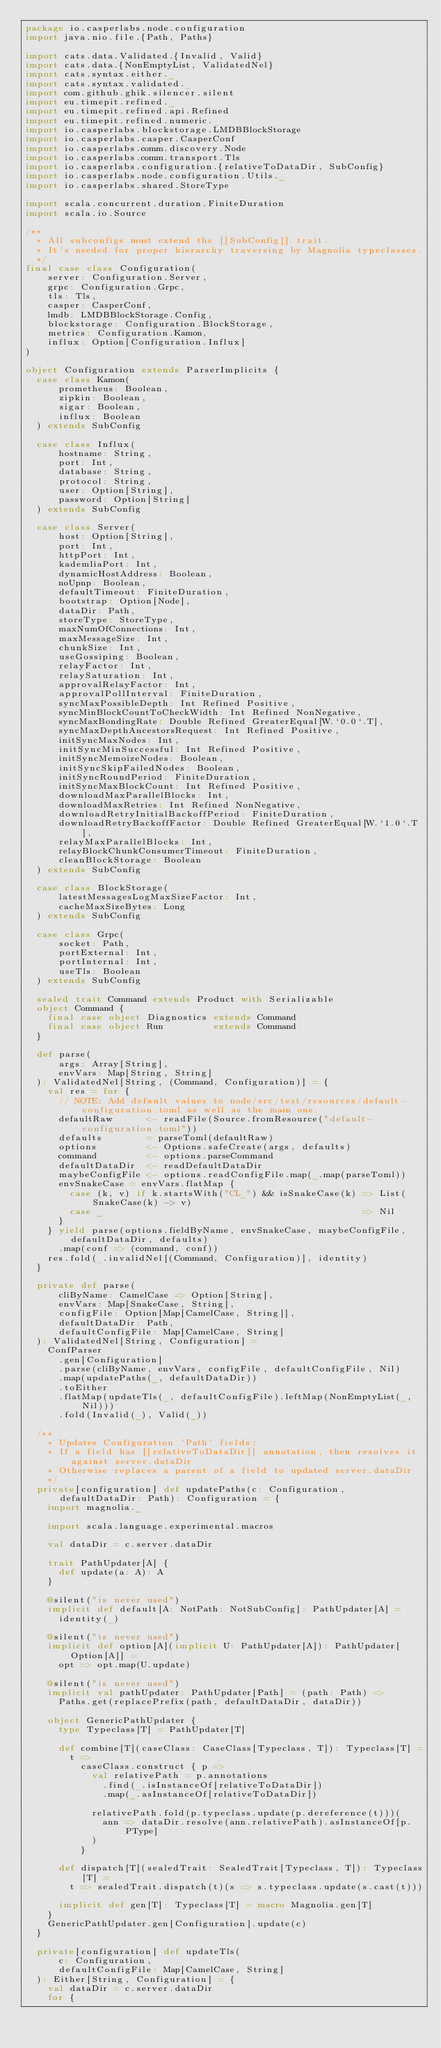Convert code to text. <code><loc_0><loc_0><loc_500><loc_500><_Scala_>package io.casperlabs.node.configuration
import java.nio.file.{Path, Paths}

import cats.data.Validated.{Invalid, Valid}
import cats.data.{NonEmptyList, ValidatedNel}
import cats.syntax.either._
import cats.syntax.validated._
import com.github.ghik.silencer.silent
import eu.timepit.refined._
import eu.timepit.refined.api.Refined
import eu.timepit.refined.numeric._
import io.casperlabs.blockstorage.LMDBBlockStorage
import io.casperlabs.casper.CasperConf
import io.casperlabs.comm.discovery.Node
import io.casperlabs.comm.transport.Tls
import io.casperlabs.configuration.{relativeToDataDir, SubConfig}
import io.casperlabs.node.configuration.Utils._
import io.casperlabs.shared.StoreType

import scala.concurrent.duration.FiniteDuration
import scala.io.Source

/**
  * All subconfigs must extend the [[SubConfig]] trait.
  * It's needed for proper hierarchy traversing by Magnolia typeclasses.
  */
final case class Configuration(
    server: Configuration.Server,
    grpc: Configuration.Grpc,
    tls: Tls,
    casper: CasperConf,
    lmdb: LMDBBlockStorage.Config,
    blockstorage: Configuration.BlockStorage,
    metrics: Configuration.Kamon,
    influx: Option[Configuration.Influx]
)

object Configuration extends ParserImplicits {
  case class Kamon(
      prometheus: Boolean,
      zipkin: Boolean,
      sigar: Boolean,
      influx: Boolean
  ) extends SubConfig

  case class Influx(
      hostname: String,
      port: Int,
      database: String,
      protocol: String,
      user: Option[String],
      password: Option[String]
  ) extends SubConfig

  case class Server(
      host: Option[String],
      port: Int,
      httpPort: Int,
      kademliaPort: Int,
      dynamicHostAddress: Boolean,
      noUpnp: Boolean,
      defaultTimeout: FiniteDuration,
      bootstrap: Option[Node],
      dataDir: Path,
      storeType: StoreType,
      maxNumOfConnections: Int,
      maxMessageSize: Int,
      chunkSize: Int,
      useGossiping: Boolean,
      relayFactor: Int,
      relaySaturation: Int,
      approvalRelayFactor: Int,
      approvalPollInterval: FiniteDuration,
      syncMaxPossibleDepth: Int Refined Positive,
      syncMinBlockCountToCheckWidth: Int Refined NonNegative,
      syncMaxBondingRate: Double Refined GreaterEqual[W.`0.0`.T],
      syncMaxDepthAncestorsRequest: Int Refined Positive,
      initSyncMaxNodes: Int,
      initSyncMinSuccessful: Int Refined Positive,
      initSyncMemoizeNodes: Boolean,
      initSyncSkipFailedNodes: Boolean,
      initSyncRoundPeriod: FiniteDuration,
      initSyncMaxBlockCount: Int Refined Positive,
      downloadMaxParallelBlocks: Int,
      downloadMaxRetries: Int Refined NonNegative,
      downloadRetryInitialBackoffPeriod: FiniteDuration,
      downloadRetryBackoffFactor: Double Refined GreaterEqual[W.`1.0`.T],
      relayMaxParallelBlocks: Int,
      relayBlockChunkConsumerTimeout: FiniteDuration,
      cleanBlockStorage: Boolean
  ) extends SubConfig

  case class BlockStorage(
      latestMessagesLogMaxSizeFactor: Int,
      cacheMaxSizeBytes: Long
  ) extends SubConfig

  case class Grpc(
      socket: Path,
      portExternal: Int,
      portInternal: Int,
      useTls: Boolean
  ) extends SubConfig

  sealed trait Command extends Product with Serializable
  object Command {
    final case object Diagnostics extends Command
    final case object Run         extends Command
  }

  def parse(
      args: Array[String],
      envVars: Map[String, String]
  ): ValidatedNel[String, (Command, Configuration)] = {
    val res = for {
      // NOTE: Add default values to node/src/test/resources/default-configuration.toml as well as the main one.
      defaultRaw      <- readFile(Source.fromResource("default-configuration.toml"))
      defaults        = parseToml(defaultRaw)
      options         <- Options.safeCreate(args, defaults)
      command         <- options.parseCommand
      defaultDataDir  <- readDefaultDataDir
      maybeConfigFile <- options.readConfigFile.map(_.map(parseToml))
      envSnakeCase = envVars.flatMap {
        case (k, v) if k.startsWith("CL_") && isSnakeCase(k) => List(SnakeCase(k) -> v)
        case _                                               => Nil
      }
    } yield parse(options.fieldByName, envSnakeCase, maybeConfigFile, defaultDataDir, defaults)
      .map(conf => (command, conf))
    res.fold(_.invalidNel[(Command, Configuration)], identity)
  }

  private def parse(
      cliByName: CamelCase => Option[String],
      envVars: Map[SnakeCase, String],
      configFile: Option[Map[CamelCase, String]],
      defaultDataDir: Path,
      defaultConfigFile: Map[CamelCase, String]
  ): ValidatedNel[String, Configuration] =
    ConfParser
      .gen[Configuration]
      .parse(cliByName, envVars, configFile, defaultConfigFile, Nil)
      .map(updatePaths(_, defaultDataDir))
      .toEither
      .flatMap(updateTls(_, defaultConfigFile).leftMap(NonEmptyList(_, Nil)))
      .fold(Invalid(_), Valid(_))

  /**
    * Updates Configuration 'Path' fields:
    * If a field has [[relativeToDataDir]] annotation, then resolves it against server.dataDir
    * Otherwise replaces a parent of a field to updated server.dataDir
    */
  private[configuration] def updatePaths(c: Configuration, defaultDataDir: Path): Configuration = {
    import magnolia._

    import scala.language.experimental.macros

    val dataDir = c.server.dataDir

    trait PathUpdater[A] {
      def update(a: A): A
    }

    @silent("is never used")
    implicit def default[A: NotPath: NotSubConfig]: PathUpdater[A] =
      identity(_)

    @silent("is never used")
    implicit def option[A](implicit U: PathUpdater[A]): PathUpdater[Option[A]] =
      opt => opt.map(U.update)

    @silent("is never used")
    implicit val pathUpdater: PathUpdater[Path] = (path: Path) =>
      Paths.get(replacePrefix(path, defaultDataDir, dataDir))

    object GenericPathUpdater {
      type Typeclass[T] = PathUpdater[T]

      def combine[T](caseClass: CaseClass[Typeclass, T]): Typeclass[T] =
        t =>
          caseClass.construct { p =>
            val relativePath = p.annotations
              .find(_.isInstanceOf[relativeToDataDir])
              .map(_.asInstanceOf[relativeToDataDir])

            relativePath.fold(p.typeclass.update(p.dereference(t)))(
              ann => dataDir.resolve(ann.relativePath).asInstanceOf[p.PType]
            )
          }

      def dispatch[T](sealedTrait: SealedTrait[Typeclass, T]): Typeclass[T] =
        t => sealedTrait.dispatch(t)(s => s.typeclass.update(s.cast(t)))

      implicit def gen[T]: Typeclass[T] = macro Magnolia.gen[T]
    }
    GenericPathUpdater.gen[Configuration].update(c)
  }

  private[configuration] def updateTls(
      c: Configuration,
      defaultConfigFile: Map[CamelCase, String]
  ): Either[String, Configuration] = {
    val dataDir = c.server.dataDir
    for {</code> 